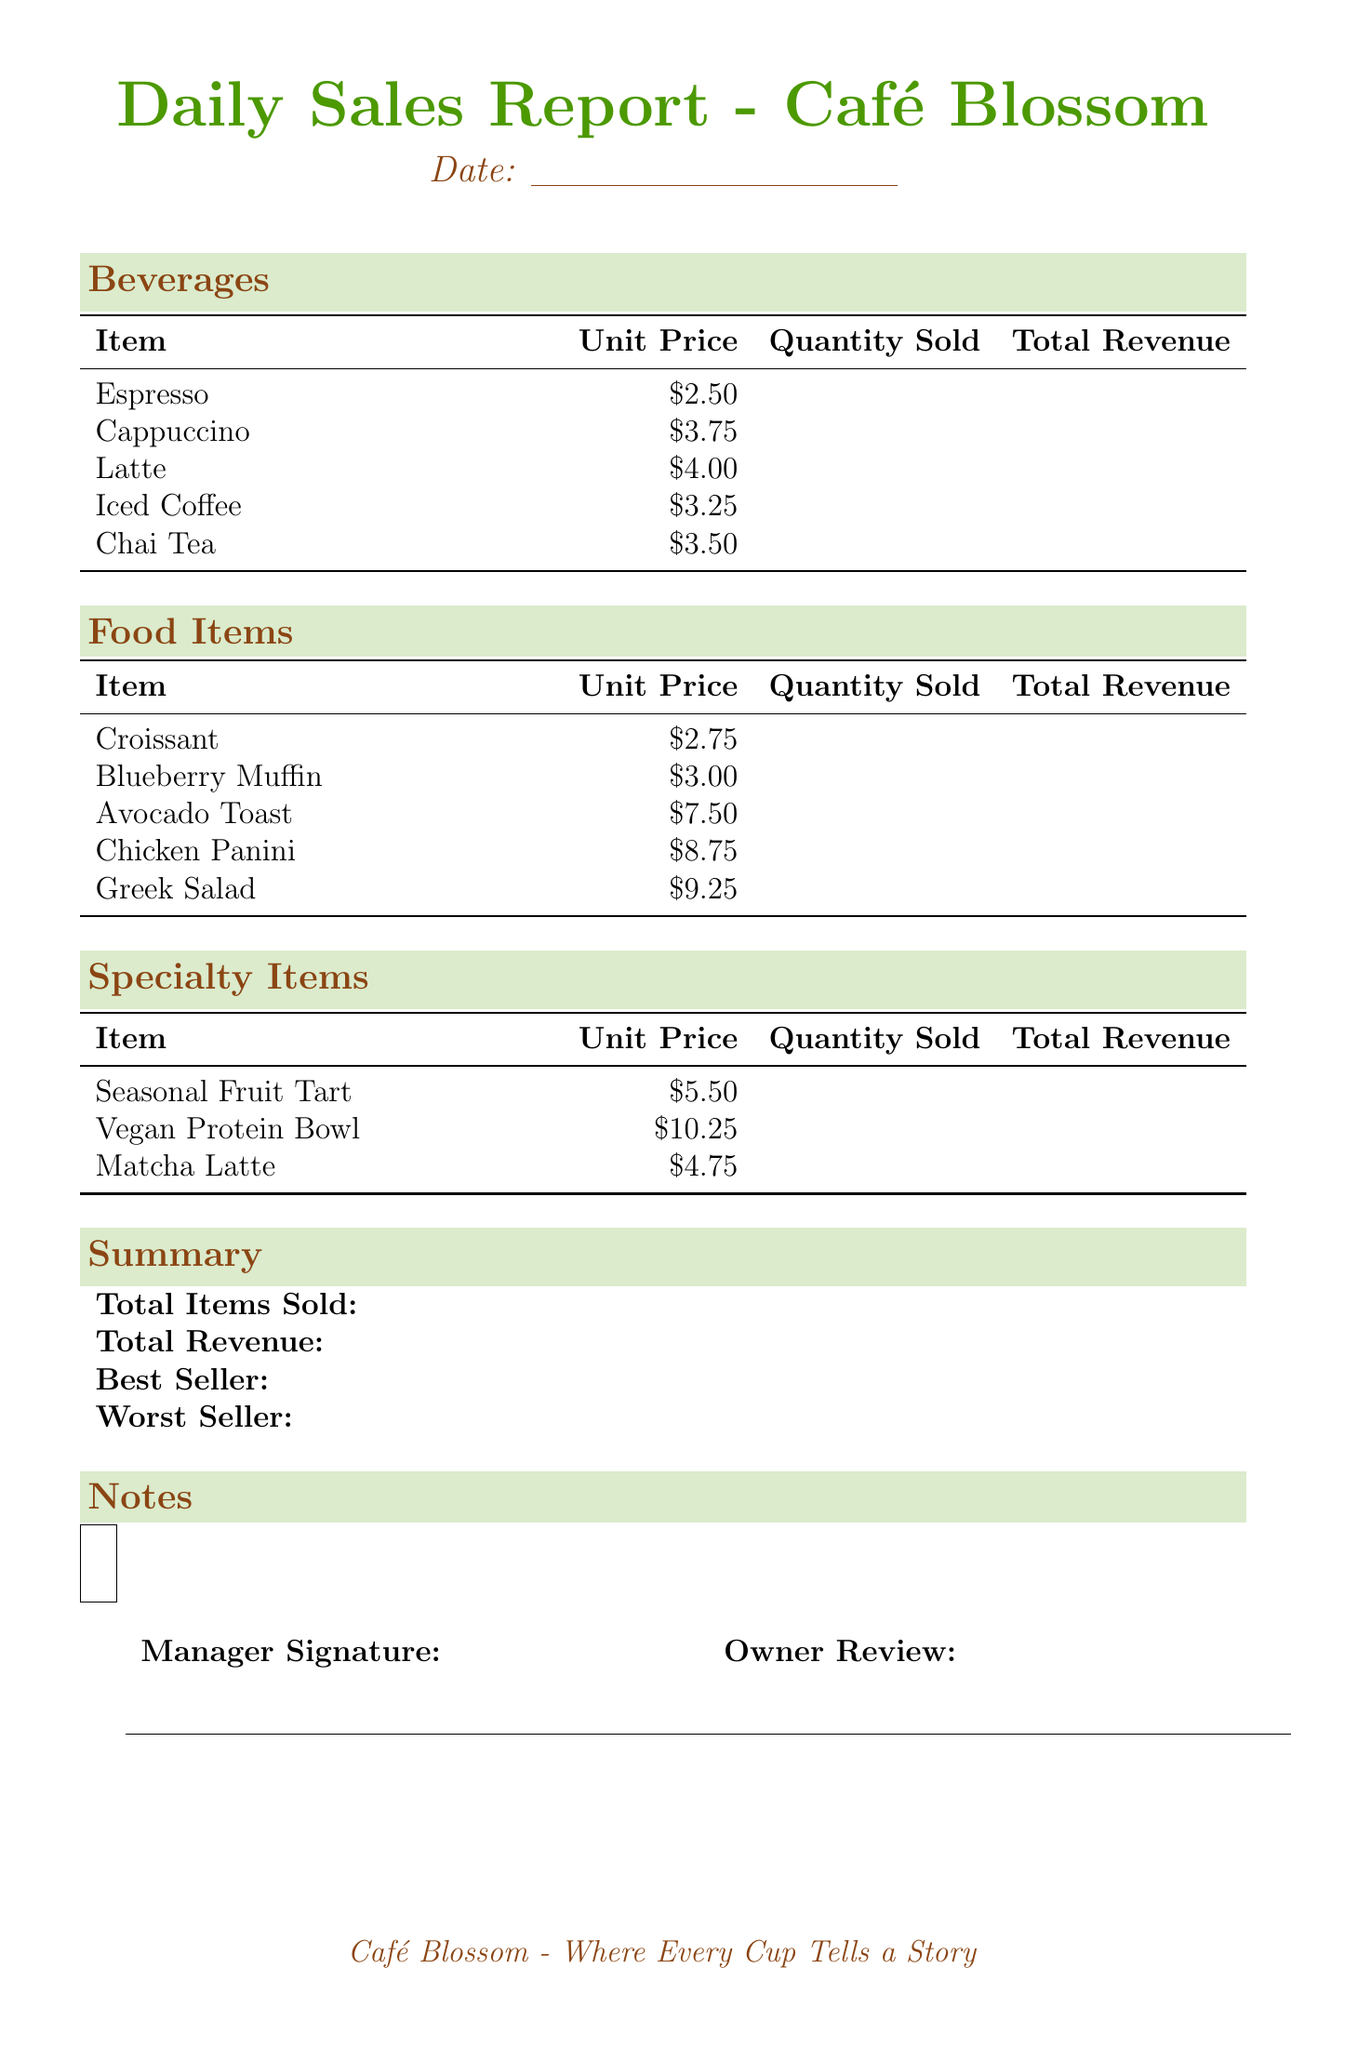what is the date of the report? The date is mentioned as a placeholder in the document and will be filled in on the actual report.
Answer: {{DATE}} what is the unit price of a cappuccino? The document lists the unit price of a cappuccino under the Beverages section.
Answer: $3.75 how many food items are listed in the report? The summary section indicates the number of food items sold.
Answer: {{TOTAL_ITEMS}} which item is listed as the best seller? According to the summary section, this is the item with the highest sales.
Answer: {{BEST_SELLER}} what is the total revenue reported? The summary section provides the total revenue generated from all sales in the document.
Answer: {{TOTAL_REVENUE}} how much is an avocado toast? The food item prices are detailed in the Food Items section, specifically for avocado toast.
Answer: $7.50 which beverage has the lowest unit price? This requires comparing unit prices of all beverages listed to find the lowest one.
Answer: Espresso who is expected to sign the document? The signature line for management is provided in the final section of the document.
Answer: {{SIGNATURE}} what type of report is this document? The title of the document indicates the nature of this report.
Answer: Daily Sales Report 